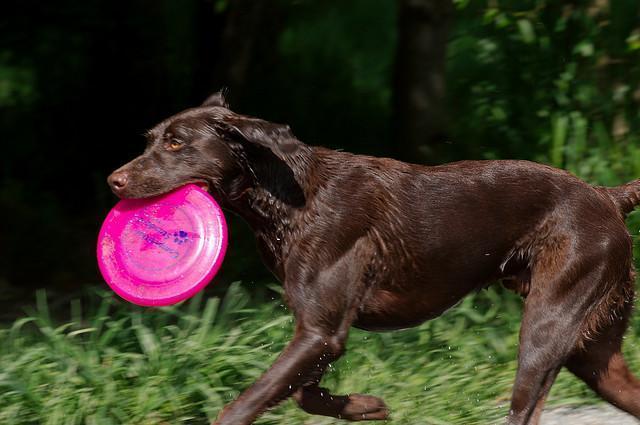How many dogs are there?
Give a very brief answer. 1. 